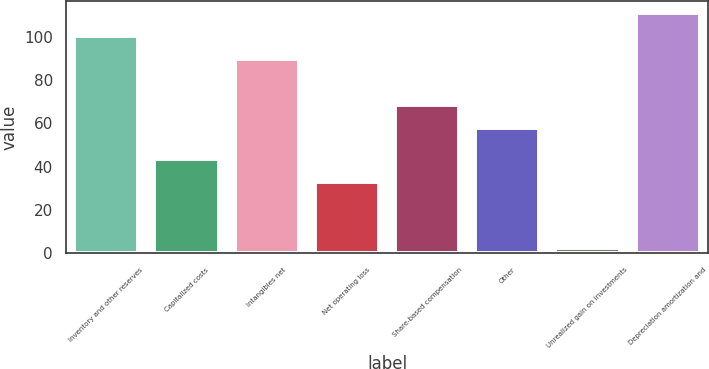Convert chart to OTSL. <chart><loc_0><loc_0><loc_500><loc_500><bar_chart><fcel>Inventory and other reserves<fcel>Capitalized costs<fcel>Intangibles net<fcel>Net operating loss<fcel>Share-based compensation<fcel>Other<fcel>Unrealized gain on investments<fcel>Depreciation amortization and<nl><fcel>100.24<fcel>43.74<fcel>89.6<fcel>33.1<fcel>68.54<fcel>57.9<fcel>2.3<fcel>110.88<nl></chart> 